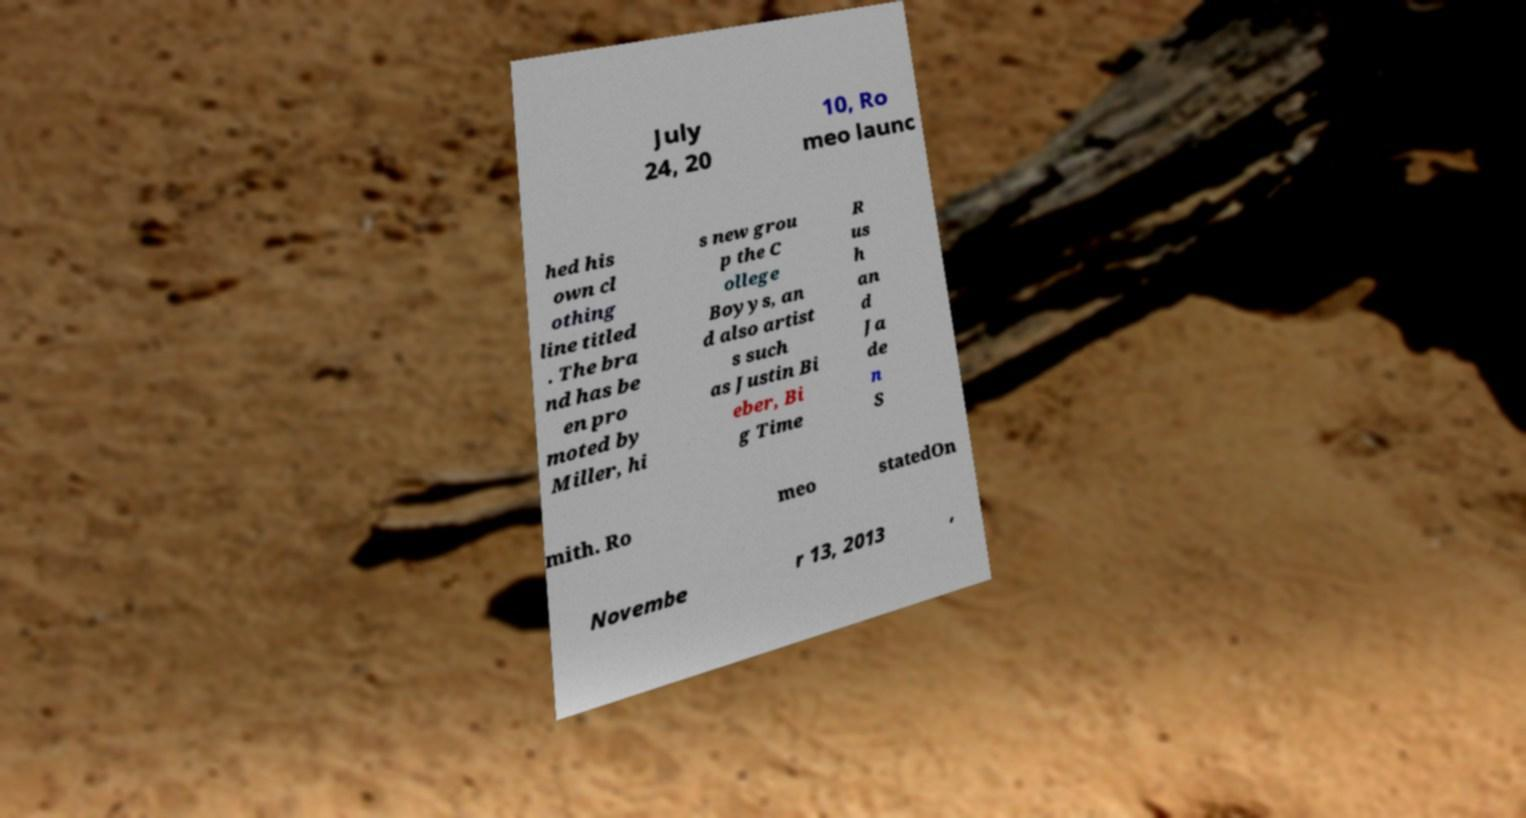What messages or text are displayed in this image? I need them in a readable, typed format. July 24, 20 10, Ro meo launc hed his own cl othing line titled . The bra nd has be en pro moted by Miller, hi s new grou p the C ollege Boyys, an d also artist s such as Justin Bi eber, Bi g Time R us h an d Ja de n S mith. Ro meo statedOn Novembe r 13, 2013 , 